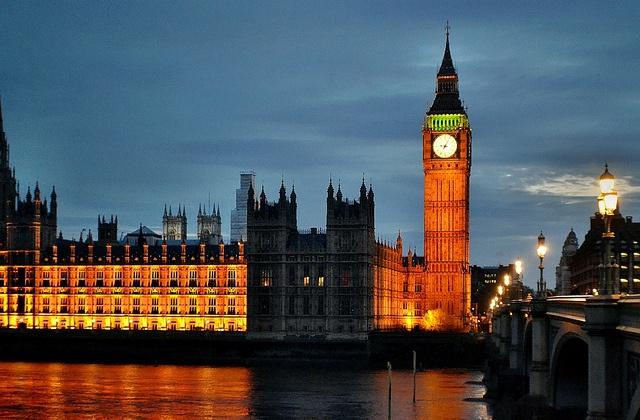Describe the objects in this image and their specific colors. I can see a clock in blue, lightyellow, khaki, and olive tones in this image. 